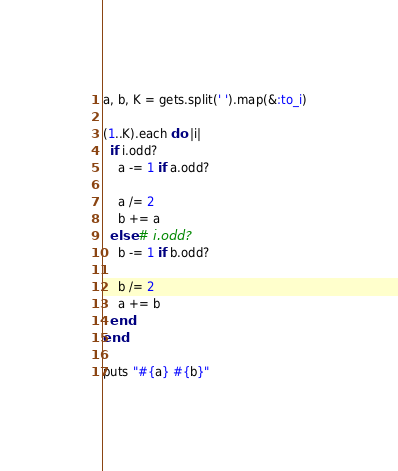<code> <loc_0><loc_0><loc_500><loc_500><_Ruby_>a, b, K = gets.split(' ').map(&:to_i)

(1..K).each do |i|
  if i.odd?
    a -= 1 if a.odd?

    a /= 2
    b += a
  else # i.odd?
    b -= 1 if b.odd?

    b /= 2
    a += b
  end
end

puts "#{a} #{b}"</code> 